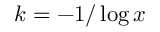<formula> <loc_0><loc_0><loc_500><loc_500>k = - 1 / \log x</formula> 